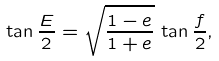Convert formula to latex. <formula><loc_0><loc_0><loc_500><loc_500>\tan \frac { E } { 2 } = \sqrt { \frac { 1 - e } { 1 + e } } \, \tan \frac { f } { 2 } ,</formula> 